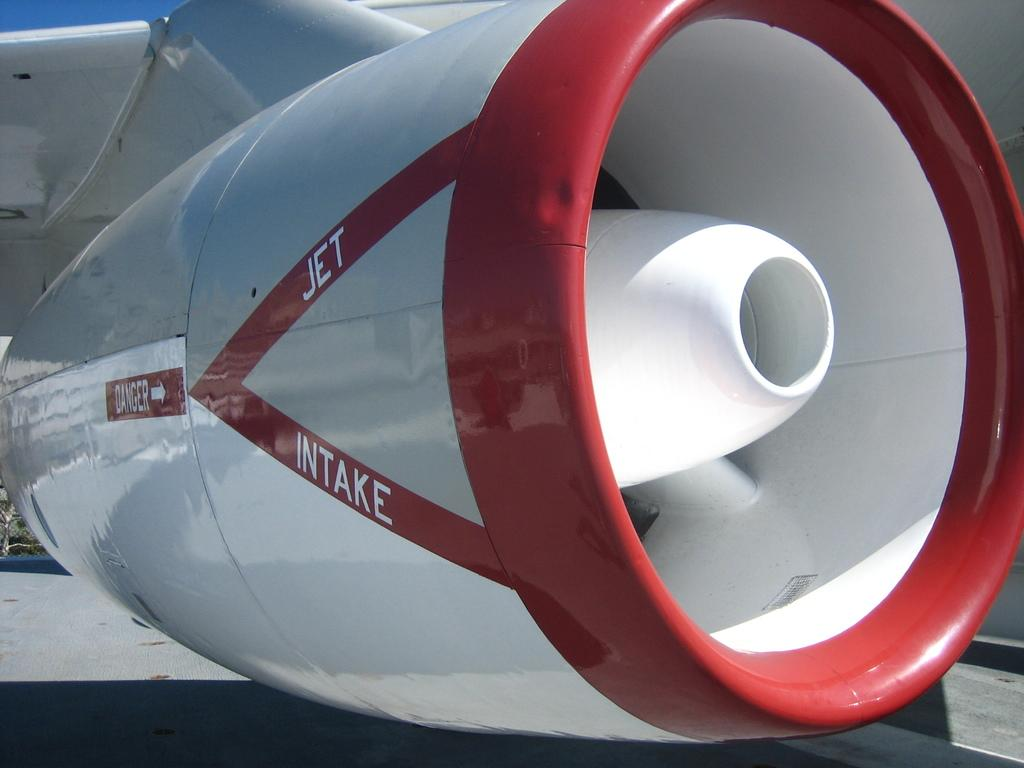Provide a one-sentence caption for the provided image. a red and white engine on a jet intake plane. 